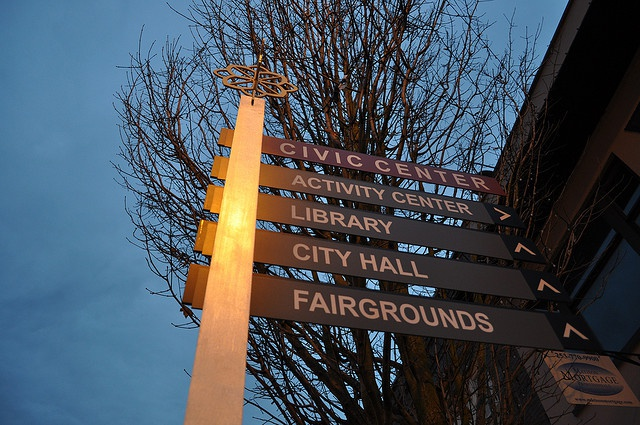Describe the objects in this image and their specific colors. I can see various objects in this image with different colors. 